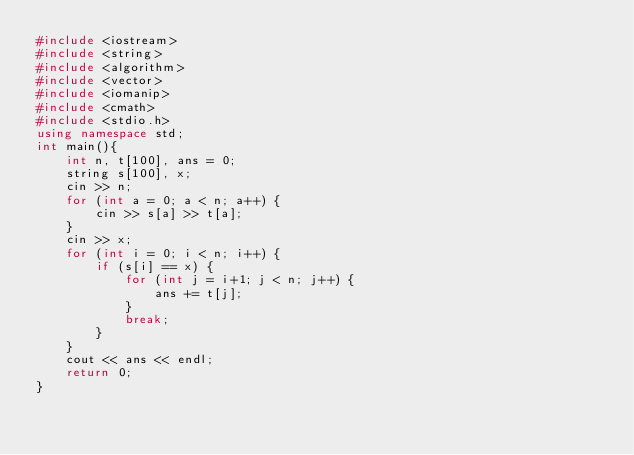<code> <loc_0><loc_0><loc_500><loc_500><_C++_>#include <iostream>
#include <string>
#include <algorithm>
#include <vector>
#include <iomanip>
#include <cmath>
#include <stdio.h>
using namespace std;
int main(){
	int n, t[100], ans = 0;
	string s[100], x;
	cin >> n;
	for (int a = 0; a < n; a++) {
		cin >> s[a] >> t[a];
	}
	cin >> x;
	for (int i = 0; i < n; i++) {
		if (s[i] == x) {
			for (int j = i+1; j < n; j++) {
				ans += t[j];
			}
			break;
		}
	}
	cout << ans << endl;
	return 0;
}

</code> 